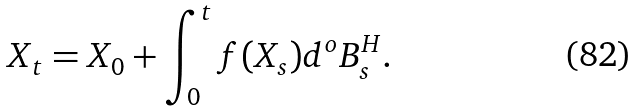Convert formula to latex. <formula><loc_0><loc_0><loc_500><loc_500>X _ { t } = X _ { 0 } + \int _ { 0 } ^ { t } f ( X _ { s } ) d ^ { o } B _ { s } ^ { H } .</formula> 